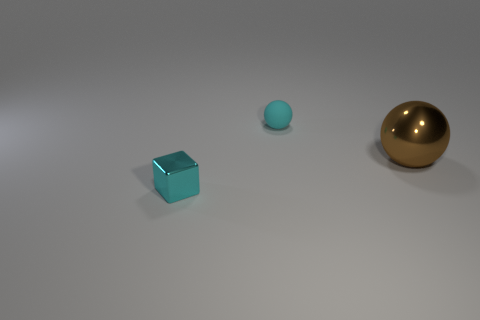Add 2 tiny cylinders. How many objects exist? 5 Subtract all blocks. How many objects are left? 2 Subtract 0 green cylinders. How many objects are left? 3 Subtract all blue blocks. Subtract all metallic things. How many objects are left? 1 Add 3 metal balls. How many metal balls are left? 4 Add 2 blue metallic balls. How many blue metallic balls exist? 2 